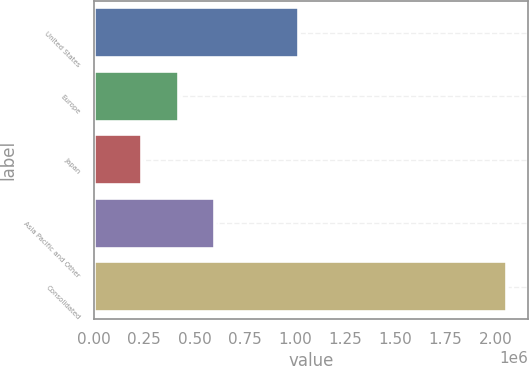Convert chart to OTSL. <chart><loc_0><loc_0><loc_500><loc_500><bar_chart><fcel>United States<fcel>Europe<fcel>Japan<fcel>Asia Pacific and Other<fcel>Consolidated<nl><fcel>1.02065e+06<fcel>420476<fcel>238588<fcel>602365<fcel>2.05747e+06<nl></chart> 